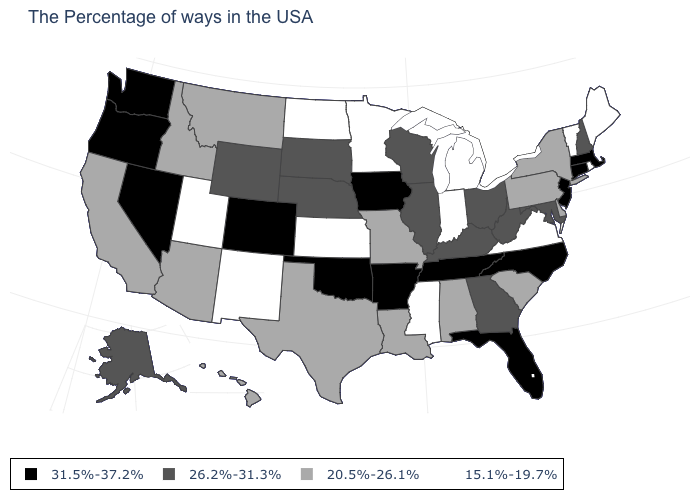What is the value of Utah?
Keep it brief. 15.1%-19.7%. What is the value of Connecticut?
Quick response, please. 31.5%-37.2%. How many symbols are there in the legend?
Keep it brief. 4. What is the value of North Carolina?
Keep it brief. 31.5%-37.2%. Name the states that have a value in the range 26.2%-31.3%?
Write a very short answer. New Hampshire, Maryland, West Virginia, Ohio, Georgia, Kentucky, Wisconsin, Illinois, Nebraska, South Dakota, Wyoming, Alaska. Name the states that have a value in the range 20.5%-26.1%?
Keep it brief. New York, Delaware, Pennsylvania, South Carolina, Alabama, Louisiana, Missouri, Texas, Montana, Arizona, Idaho, California, Hawaii. Which states have the lowest value in the USA?
Give a very brief answer. Maine, Rhode Island, Vermont, Virginia, Michigan, Indiana, Mississippi, Minnesota, Kansas, North Dakota, New Mexico, Utah. What is the value of North Dakota?
Quick response, please. 15.1%-19.7%. What is the lowest value in states that border New Hampshire?
Answer briefly. 15.1%-19.7%. Is the legend a continuous bar?
Quick response, please. No. Which states have the lowest value in the USA?
Keep it brief. Maine, Rhode Island, Vermont, Virginia, Michigan, Indiana, Mississippi, Minnesota, Kansas, North Dakota, New Mexico, Utah. Is the legend a continuous bar?
Be succinct. No. What is the lowest value in the USA?
Write a very short answer. 15.1%-19.7%. Name the states that have a value in the range 20.5%-26.1%?
Short answer required. New York, Delaware, Pennsylvania, South Carolina, Alabama, Louisiana, Missouri, Texas, Montana, Arizona, Idaho, California, Hawaii. What is the highest value in the USA?
Concise answer only. 31.5%-37.2%. 